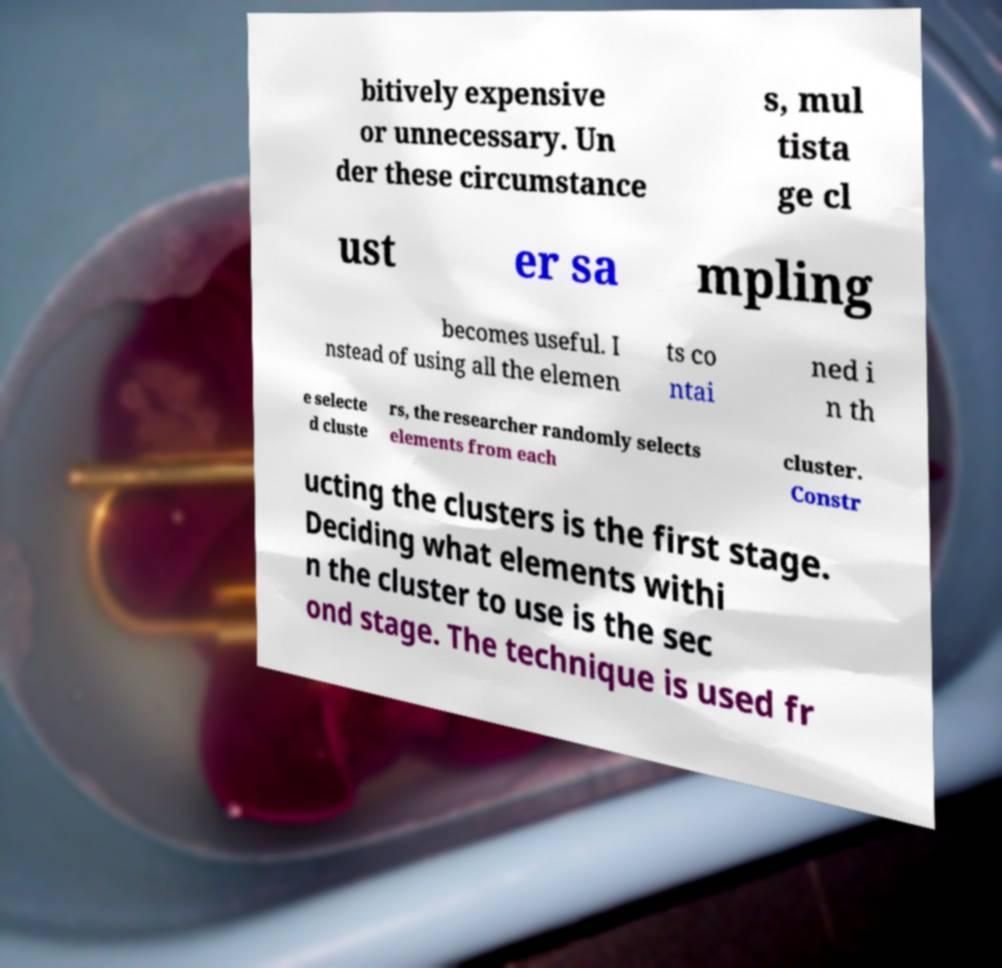What messages or text are displayed in this image? I need them in a readable, typed format. bitively expensive or unnecessary. Un der these circumstance s, mul tista ge cl ust er sa mpling becomes useful. I nstead of using all the elemen ts co ntai ned i n th e selecte d cluste rs, the researcher randomly selects elements from each cluster. Constr ucting the clusters is the first stage. Deciding what elements withi n the cluster to use is the sec ond stage. The technique is used fr 